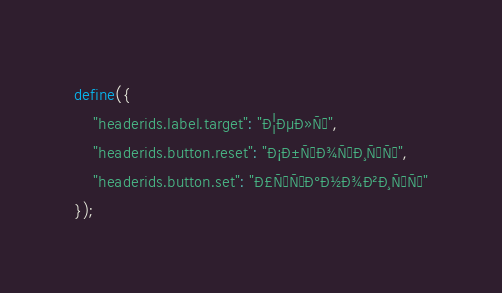<code> <loc_0><loc_0><loc_500><loc_500><_JavaScript_>define({
	"headerids.label.target": "Ð¦ÐµÐ»Ñ",
	"headerids.button.reset": "Ð¡Ð±ÑÐ¾ÑÐ¸ÑÑ",
	"headerids.button.set": "Ð£ÑÑÐ°Ð½Ð¾Ð²Ð¸ÑÑ"
});
</code> 